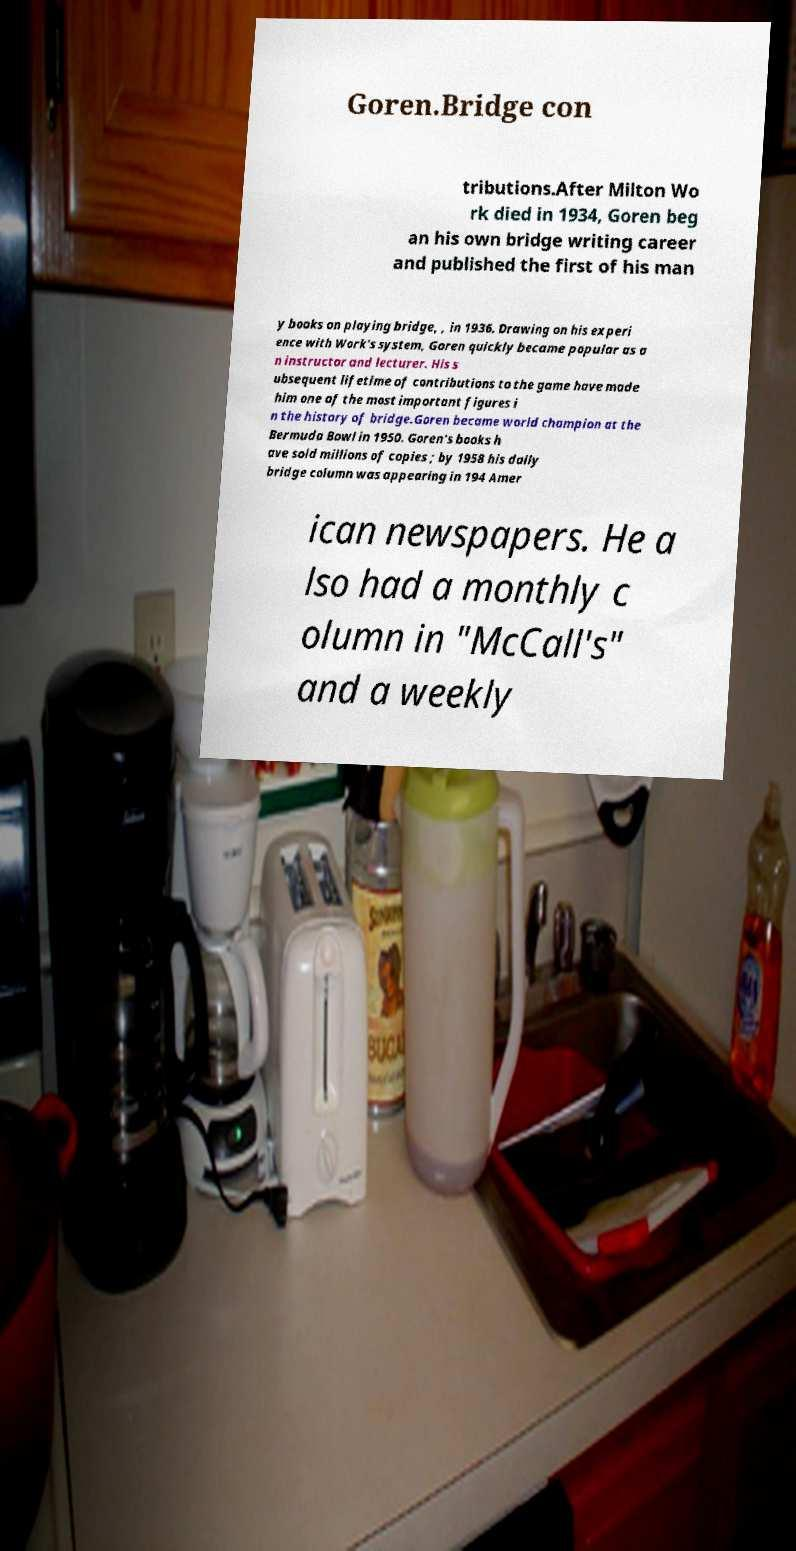Can you accurately transcribe the text from the provided image for me? Goren.Bridge con tributions.After Milton Wo rk died in 1934, Goren beg an his own bridge writing career and published the first of his man y books on playing bridge, , in 1936. Drawing on his experi ence with Work's system, Goren quickly became popular as a n instructor and lecturer. His s ubsequent lifetime of contributions to the game have made him one of the most important figures i n the history of bridge.Goren became world champion at the Bermuda Bowl in 1950. Goren's books h ave sold millions of copies ; by 1958 his daily bridge column was appearing in 194 Amer ican newspapers. He a lso had a monthly c olumn in "McCall's" and a weekly 